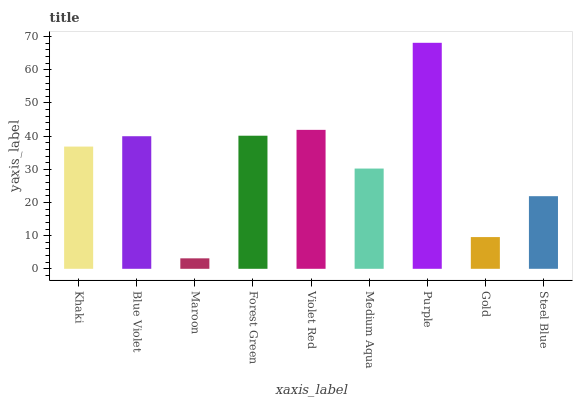Is Blue Violet the minimum?
Answer yes or no. No. Is Blue Violet the maximum?
Answer yes or no. No. Is Blue Violet greater than Khaki?
Answer yes or no. Yes. Is Khaki less than Blue Violet?
Answer yes or no. Yes. Is Khaki greater than Blue Violet?
Answer yes or no. No. Is Blue Violet less than Khaki?
Answer yes or no. No. Is Khaki the high median?
Answer yes or no. Yes. Is Khaki the low median?
Answer yes or no. Yes. Is Forest Green the high median?
Answer yes or no. No. Is Purple the low median?
Answer yes or no. No. 